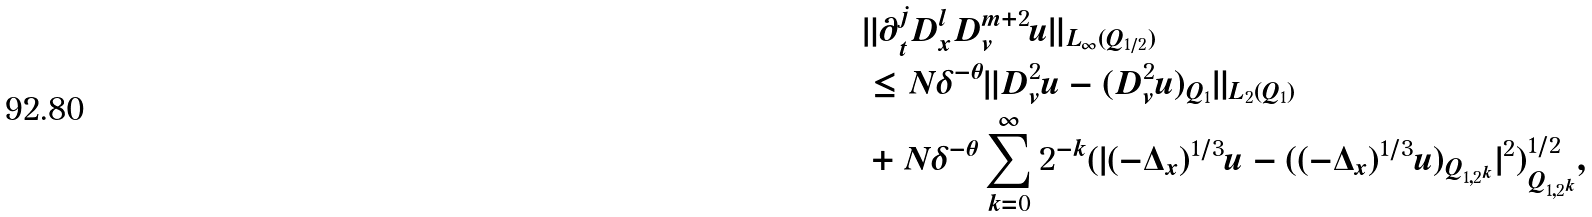<formula> <loc_0><loc_0><loc_500><loc_500>\, & \| \partial _ { t } ^ { j } D ^ { l } _ { x } D _ { v } ^ { m + 2 } u \| _ { L _ { \infty } ( Q _ { 1 / 2 } ) } \\ & \leq N \delta ^ { - \theta } \| D _ { v } ^ { 2 } u - ( D _ { v } ^ { 2 } u ) _ { Q _ { 1 } } \| _ { L _ { 2 } ( Q _ { 1 } ) } \\ & + N \delta ^ { - \theta } \sum _ { k = 0 } ^ { \infty } 2 ^ { - k } ( | ( - \Delta _ { x } ) ^ { 1 / 3 } u - ( ( - \Delta _ { x } ) ^ { 1 / 3 } u ) _ { Q _ { 1 , 2 ^ { k } } } | ^ { 2 } ) _ { Q _ { 1 , 2 ^ { k } } } ^ { 1 / 2 } ,</formula> 